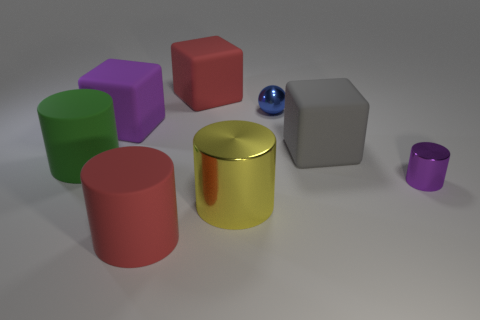Subtract 1 cylinders. How many cylinders are left? 3 Subtract all large green matte cylinders. How many cylinders are left? 3 Subtract all blue cylinders. Subtract all green blocks. How many cylinders are left? 4 Add 1 large brown blocks. How many objects exist? 9 Subtract all spheres. How many objects are left? 7 Subtract 1 purple cubes. How many objects are left? 7 Subtract all purple matte objects. Subtract all small gray objects. How many objects are left? 7 Add 8 red cylinders. How many red cylinders are left? 9 Add 3 big red cubes. How many big red cubes exist? 4 